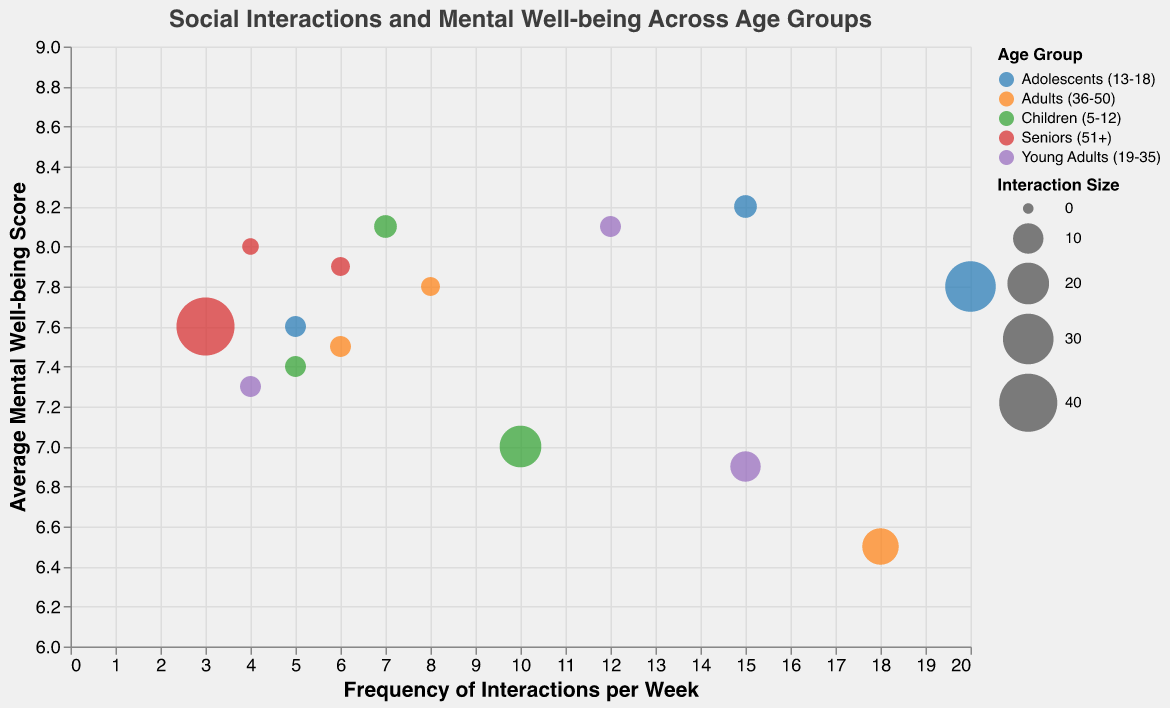How many different Age Groups are depicted in the bubble chart? Observing the color legend on the chart, there are distinct color categories representing each Age Group. By counting them, we determine that there are five Age Groups.
Answer: 5 Which Age Group shows the highest Average Mental Well-being Score and with which type of interaction? To identify this, we need to look for the bubble that is placed highest on the Y-axis and then note its corresponding Age Group and Type of Interaction. The bubble representing Adolescents (13-18) interacting with Friends shows the highest score of 8.2.
Answer: Adolescents (13-18), Friends What is the Frequency of Interactions per Week for Young Adults (19-35) with their Family and how does it compare to Children (5-12) with their Family? Observe the X-axis values for the bubbles corresponding to these two Age Groups with Family interactions. Young Adults have a frequency of 4, while Children have a frequency of 7. Thus, Children interact more frequently with their family than Young Adults.
Answer: Young Adults: 4, Children: 7 How does the Interaction Size of 'Community Groups' for Seniors (51+) compare to the Interaction Size of 'Schoolmates' for Children (5-12)? Check the legend for Interaction Size, which is reflected by the bubble size. The Seniors' Community Groups interaction size is significantly larger (40) compared to the Children's Schoolmates (20).
Answer: Seniors: 40, Children: 20 Which type of interaction has the lowest Average Mental Well-being Score for Adults (36-50)? Locate the bubbles for the Adults (36-50) group and compare their Y-axis positions (Average Mental Well-being Score). The lowest score is 6.5 for interactions with Colleagues.
Answer: Colleagues Comparing the Frequency of Interactions per Week, who interacts more with Friends: Adolescents (13-18) or Young Adults (19-35)? Identify the X-axis values for the bubbles belonging to these Age Groups with Friends interactions. Adolescents interact 15 times per week, whereas Young Adults interact 12 times per week with Friends. Thus, Adolescents interact more frequently.
Answer: Adolescents: 15, Young Adults: 12 What is the difference in Average Mental Well-being Score between the interactions with Friends for Children (5-12) and Seniors (51+)? Examine the respective Y-axis values for interactions with Friends. Children have a score of 7.4 and Seniors have a score of 8.0, yielding a difference of 8.0 - 7.4 = 0.6.
Answer: 0.6 What insights can we gather about the frequency and well-being score for Adolescents interacting with Schoolmates compared to Children? Compare the X-axis (Frequency) and Y-axis (Average Mental Well-being Score) for these groups. Adolescents interact more frequently (20) with Schoolmates than Children (10) and also have a higher Well-being Score (7.8 vs. 7.0).
Answer: Adolescents interact more frequently and have higher well-being scores with Schoolmates compared to Children Which type of interaction has the largest bubble size in the chart and for which Age Group does it belong? Identify the largest bubble by visual inspection regarding its size. The largest bubble represents Community Groups interaction for Seniors (51+), with a size of 40.
Answer: Community Groups, Seniors (51+) What is the average frequency of Family interactions per week across all Age Groups? To find this, sum the frequencies of Family interactions across all Age Groups and then divide by the number of groups. (7 + 5 + 4 + 6 + 6) / 5 = 28 / 5 = 5.6.
Answer: 5.6 